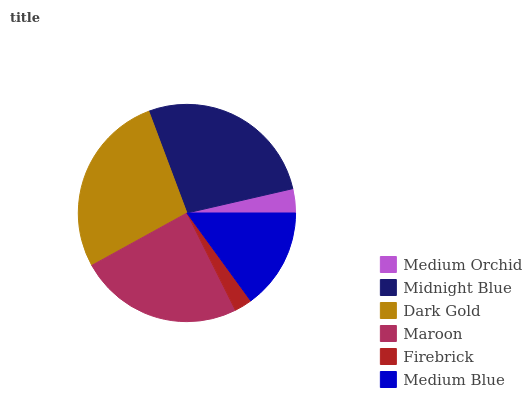Is Firebrick the minimum?
Answer yes or no. Yes. Is Dark Gold the maximum?
Answer yes or no. Yes. Is Midnight Blue the minimum?
Answer yes or no. No. Is Midnight Blue the maximum?
Answer yes or no. No. Is Midnight Blue greater than Medium Orchid?
Answer yes or no. Yes. Is Medium Orchid less than Midnight Blue?
Answer yes or no. Yes. Is Medium Orchid greater than Midnight Blue?
Answer yes or no. No. Is Midnight Blue less than Medium Orchid?
Answer yes or no. No. Is Maroon the high median?
Answer yes or no. Yes. Is Medium Blue the low median?
Answer yes or no. Yes. Is Midnight Blue the high median?
Answer yes or no. No. Is Firebrick the low median?
Answer yes or no. No. 